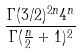Convert formula to latex. <formula><loc_0><loc_0><loc_500><loc_500>\frac { \Gamma ( 3 / 2 ) ^ { 2 n } 4 ^ { n } } { \Gamma ( \frac { n } { 2 } + 1 ) ^ { 2 } }</formula> 